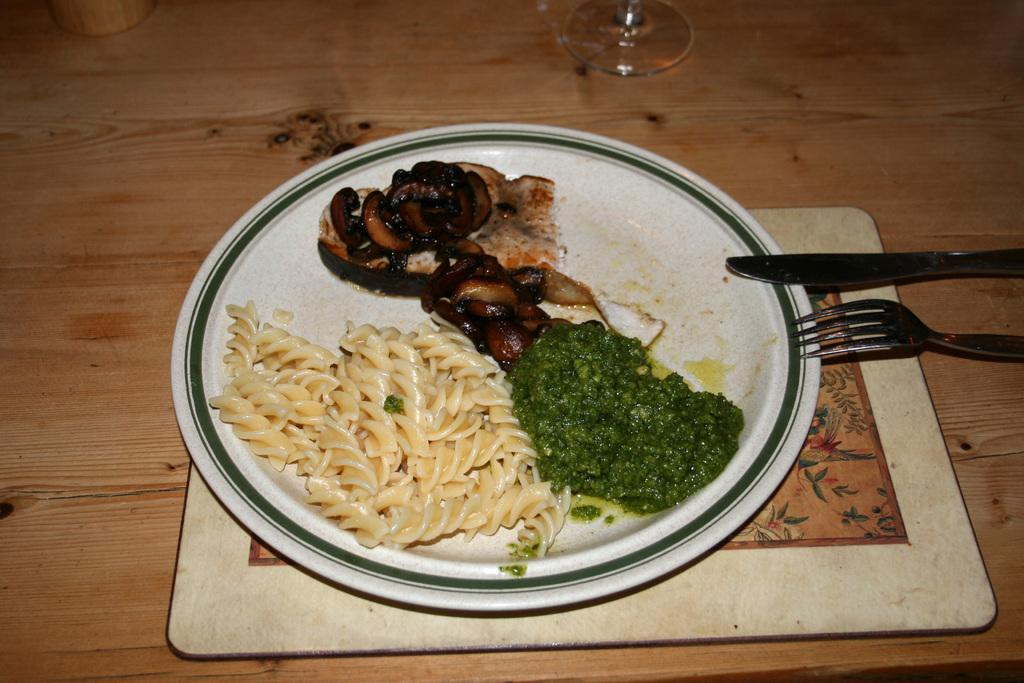What is on the plate that is visible in the image? The plate contains food items. What is the plate placed on in the image? The plate is placed on a wooden object. What utensils are present near the plate in the image? There is a knife and a fork on the right side of the plate. What is the glass used for in the image? The glass is likely used for holding a beverage. What type of soda is being poured into the glass in the image? There is no soda present in the image; it only shows a plate with food items, utensils, and a glass. How many oranges are visible on the plate in the image? There are no oranges visible on the plate in the image. 